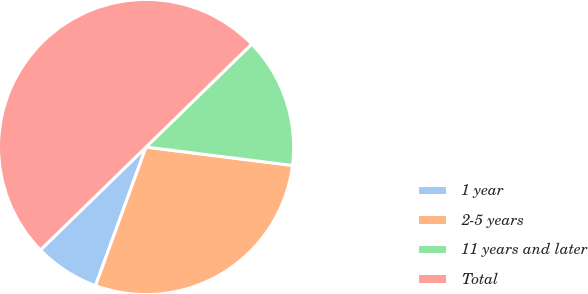Convert chart to OTSL. <chart><loc_0><loc_0><loc_500><loc_500><pie_chart><fcel>1 year<fcel>2-5 years<fcel>11 years and later<fcel>Total<nl><fcel>7.14%<fcel>28.57%<fcel>14.29%<fcel>50.0%<nl></chart> 